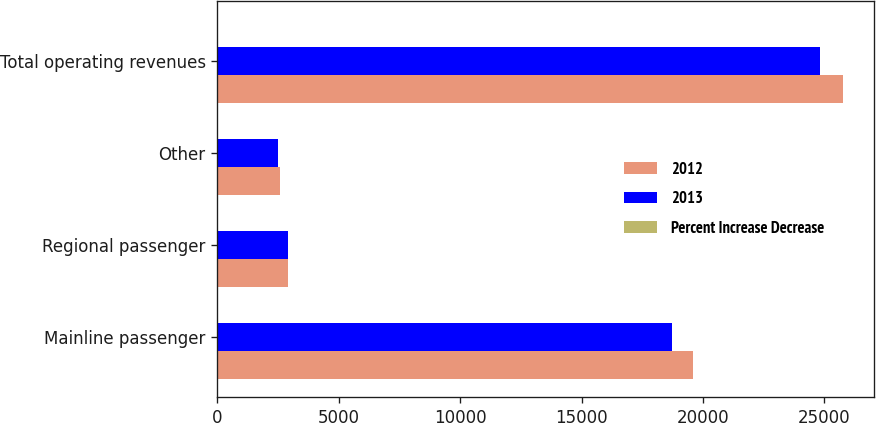Convert chart. <chart><loc_0><loc_0><loc_500><loc_500><stacked_bar_chart><ecel><fcel>Mainline passenger<fcel>Regional passenger<fcel>Other<fcel>Total operating revenues<nl><fcel>2012<fcel>19594<fcel>2927<fcel>2563<fcel>25760<nl><fcel>2013<fcel>18743<fcel>2914<fcel>2493<fcel>24825<nl><fcel>Percent Increase Decrease<fcel>4.5<fcel>0.5<fcel>2.8<fcel>3.8<nl></chart> 